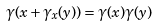<formula> <loc_0><loc_0><loc_500><loc_500>\gamma ( x + \gamma _ { x } ( y ) ) = \gamma ( x ) \gamma ( y )</formula> 